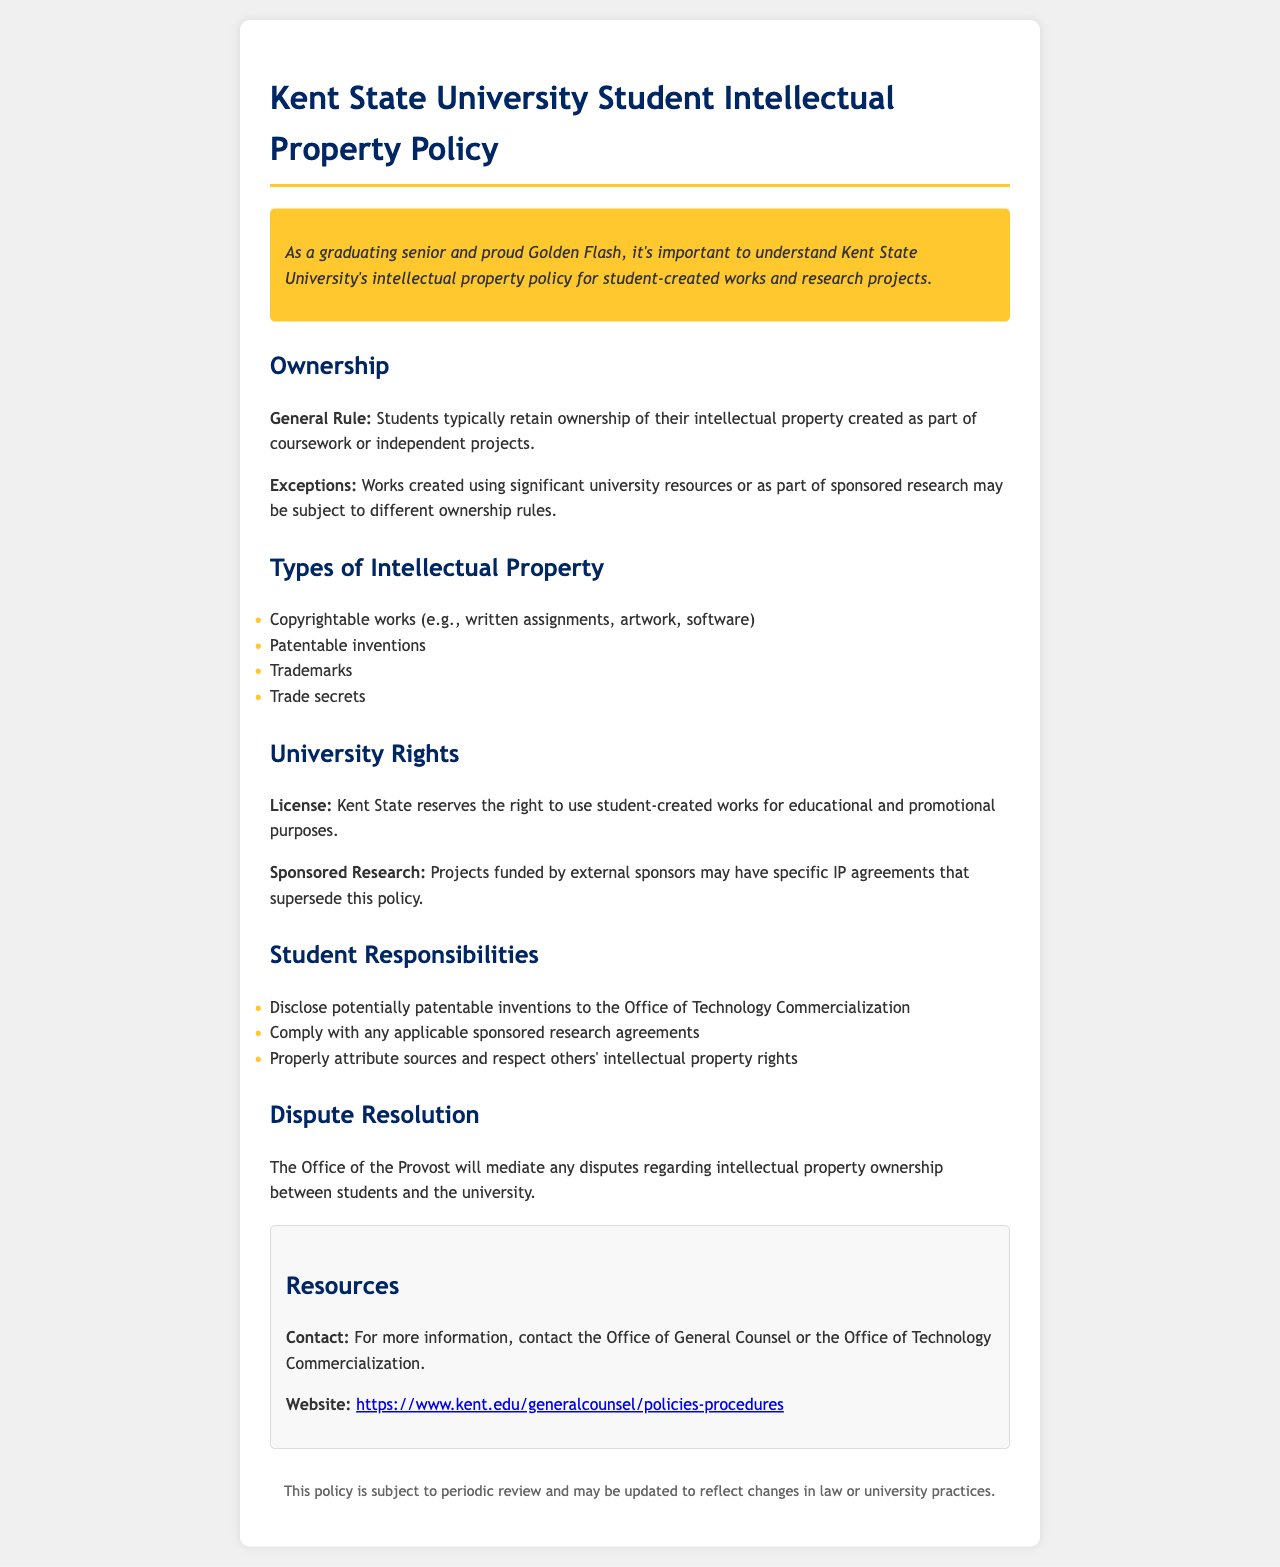What is the general rule for ownership of student-created works? The document states that students typically retain ownership of their intellectual property created as part of coursework or independent projects.
Answer: Students typically retain ownership What are the four types of intellectual property listed? The document lists copyrightable works, patentable inventions, trademarks, and trade secrets as types of intellectual property.
Answer: Copyrightable works, patentable inventions, trademarks, trade secrets What right does Kent State reserve regarding student-created works? The document mentions that Kent State reserves the right to use student-created works for educational and promotional purposes.
Answer: Use for educational and promotional purposes Who mediates disputes regarding intellectual property ownership? The document specifies that the Office of the Provost will mediate any disputes regarding intellectual property ownership between students and the university.
Answer: Office of the Provost What must students disclose to the Office of Technology Commercialization? The document states that students must disclose potentially patentable inventions to the Office of Technology Commercialization.
Answer: Potentially patentable inventions What should students do to respect others' intellectual property rights? Students are required to properly attribute sources in order to respect others' intellectual property rights as indicated in the document.
Answer: Properly attribute sources What is available for more information on the policy? The document provides a contact and a website link for obtaining more information regarding the policy.
Answer: Office of General Counsel or the Office of Technology Commercialization What may affect ownership rules for student-created works? The document notes that works created using significant university resources or as part of sponsored research may be subject to different ownership rules.
Answer: Significant university resources or sponsored research 